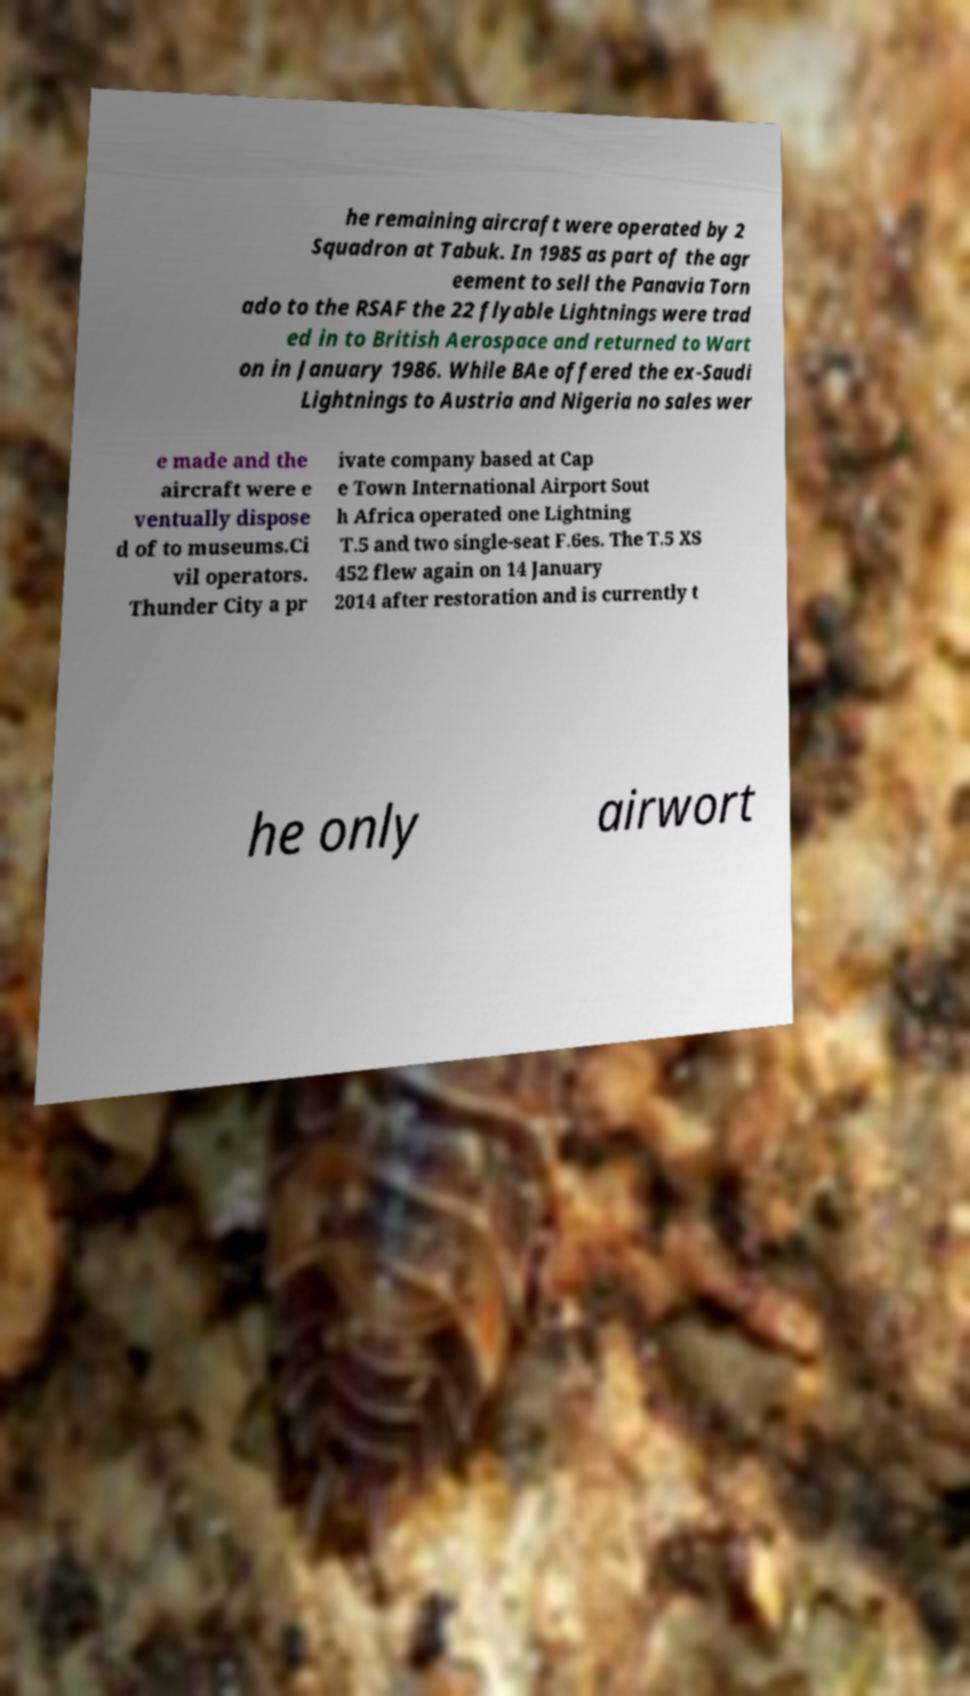Please read and relay the text visible in this image. What does it say? he remaining aircraft were operated by 2 Squadron at Tabuk. In 1985 as part of the agr eement to sell the Panavia Torn ado to the RSAF the 22 flyable Lightnings were trad ed in to British Aerospace and returned to Wart on in January 1986. While BAe offered the ex-Saudi Lightnings to Austria and Nigeria no sales wer e made and the aircraft were e ventually dispose d of to museums.Ci vil operators. Thunder City a pr ivate company based at Cap e Town International Airport Sout h Africa operated one Lightning T.5 and two single-seat F.6es. The T.5 XS 452 flew again on 14 January 2014 after restoration and is currently t he only airwort 